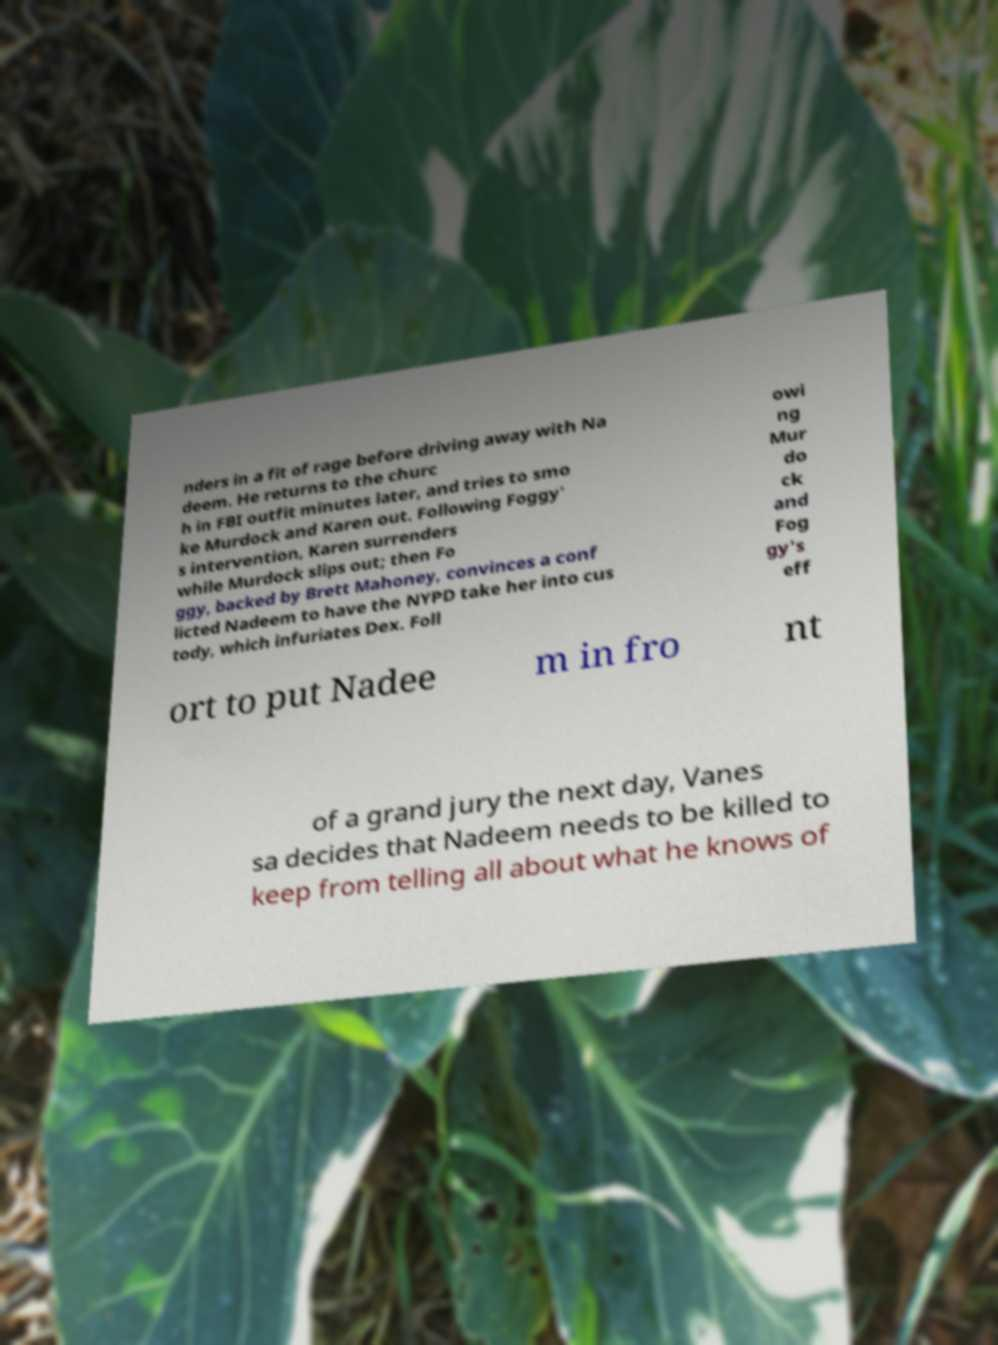Could you extract and type out the text from this image? nders in a fit of rage before driving away with Na deem. He returns to the churc h in FBI outfit minutes later, and tries to smo ke Murdock and Karen out. Following Foggy' s intervention, Karen surrenders while Murdock slips out; then Fo ggy, backed by Brett Mahoney, convinces a conf licted Nadeem to have the NYPD take her into cus tody, which infuriates Dex. Foll owi ng Mur do ck and Fog gy's eff ort to put Nadee m in fro nt of a grand jury the next day, Vanes sa decides that Nadeem needs to be killed to keep from telling all about what he knows of 